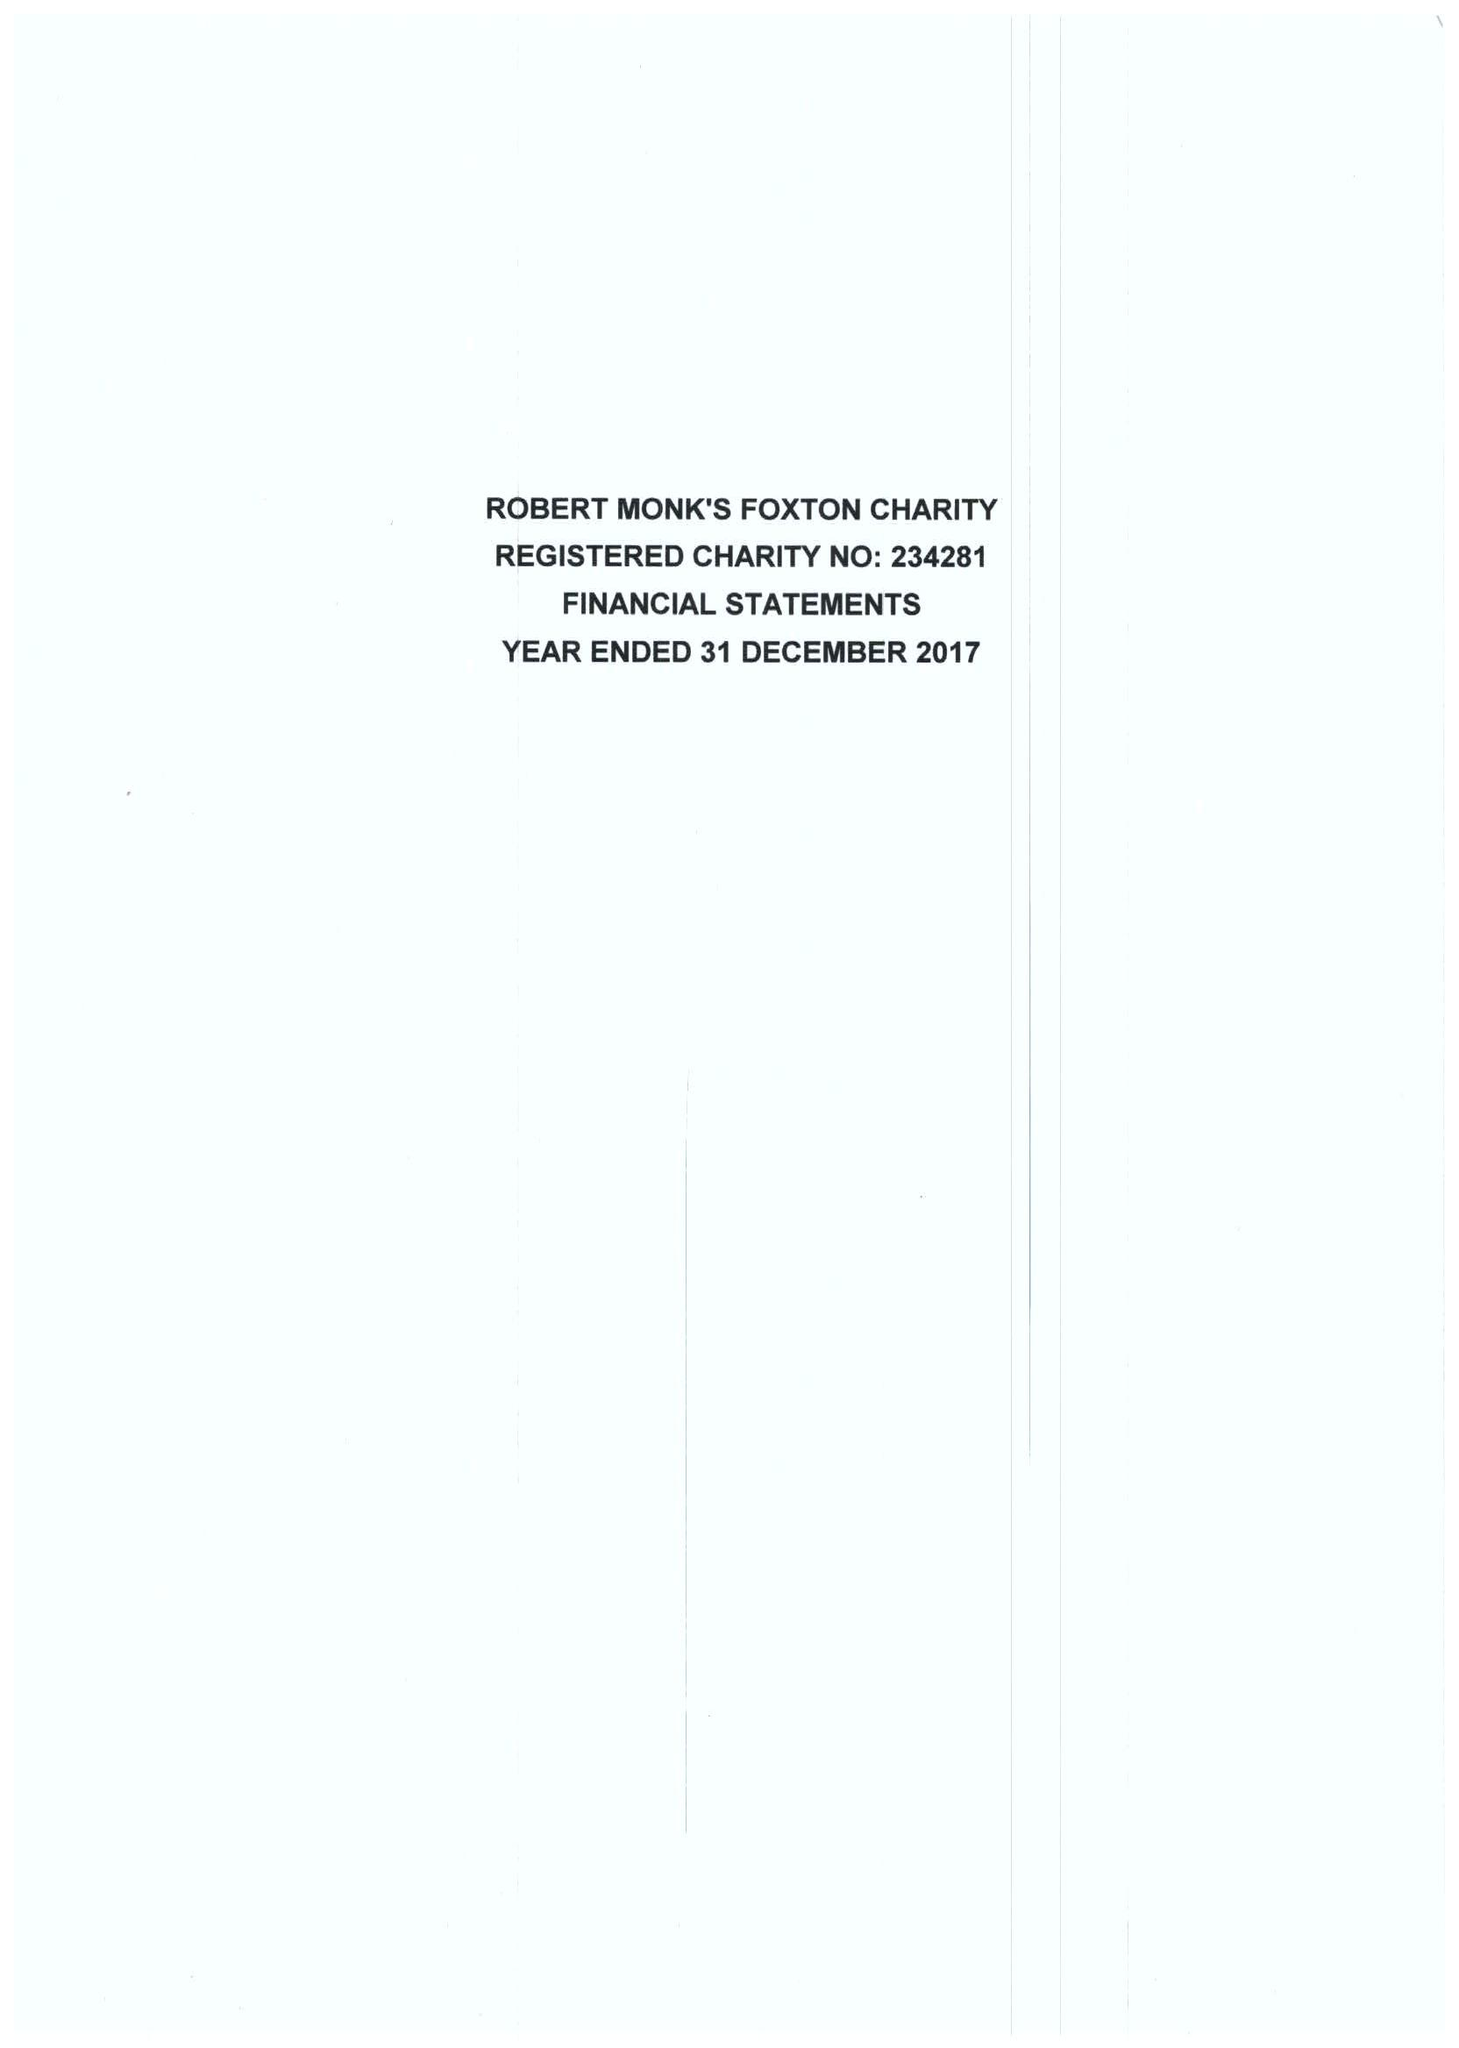What is the value for the address__post_town?
Answer the question using a single word or phrase. MARKET HARBOROUGH 